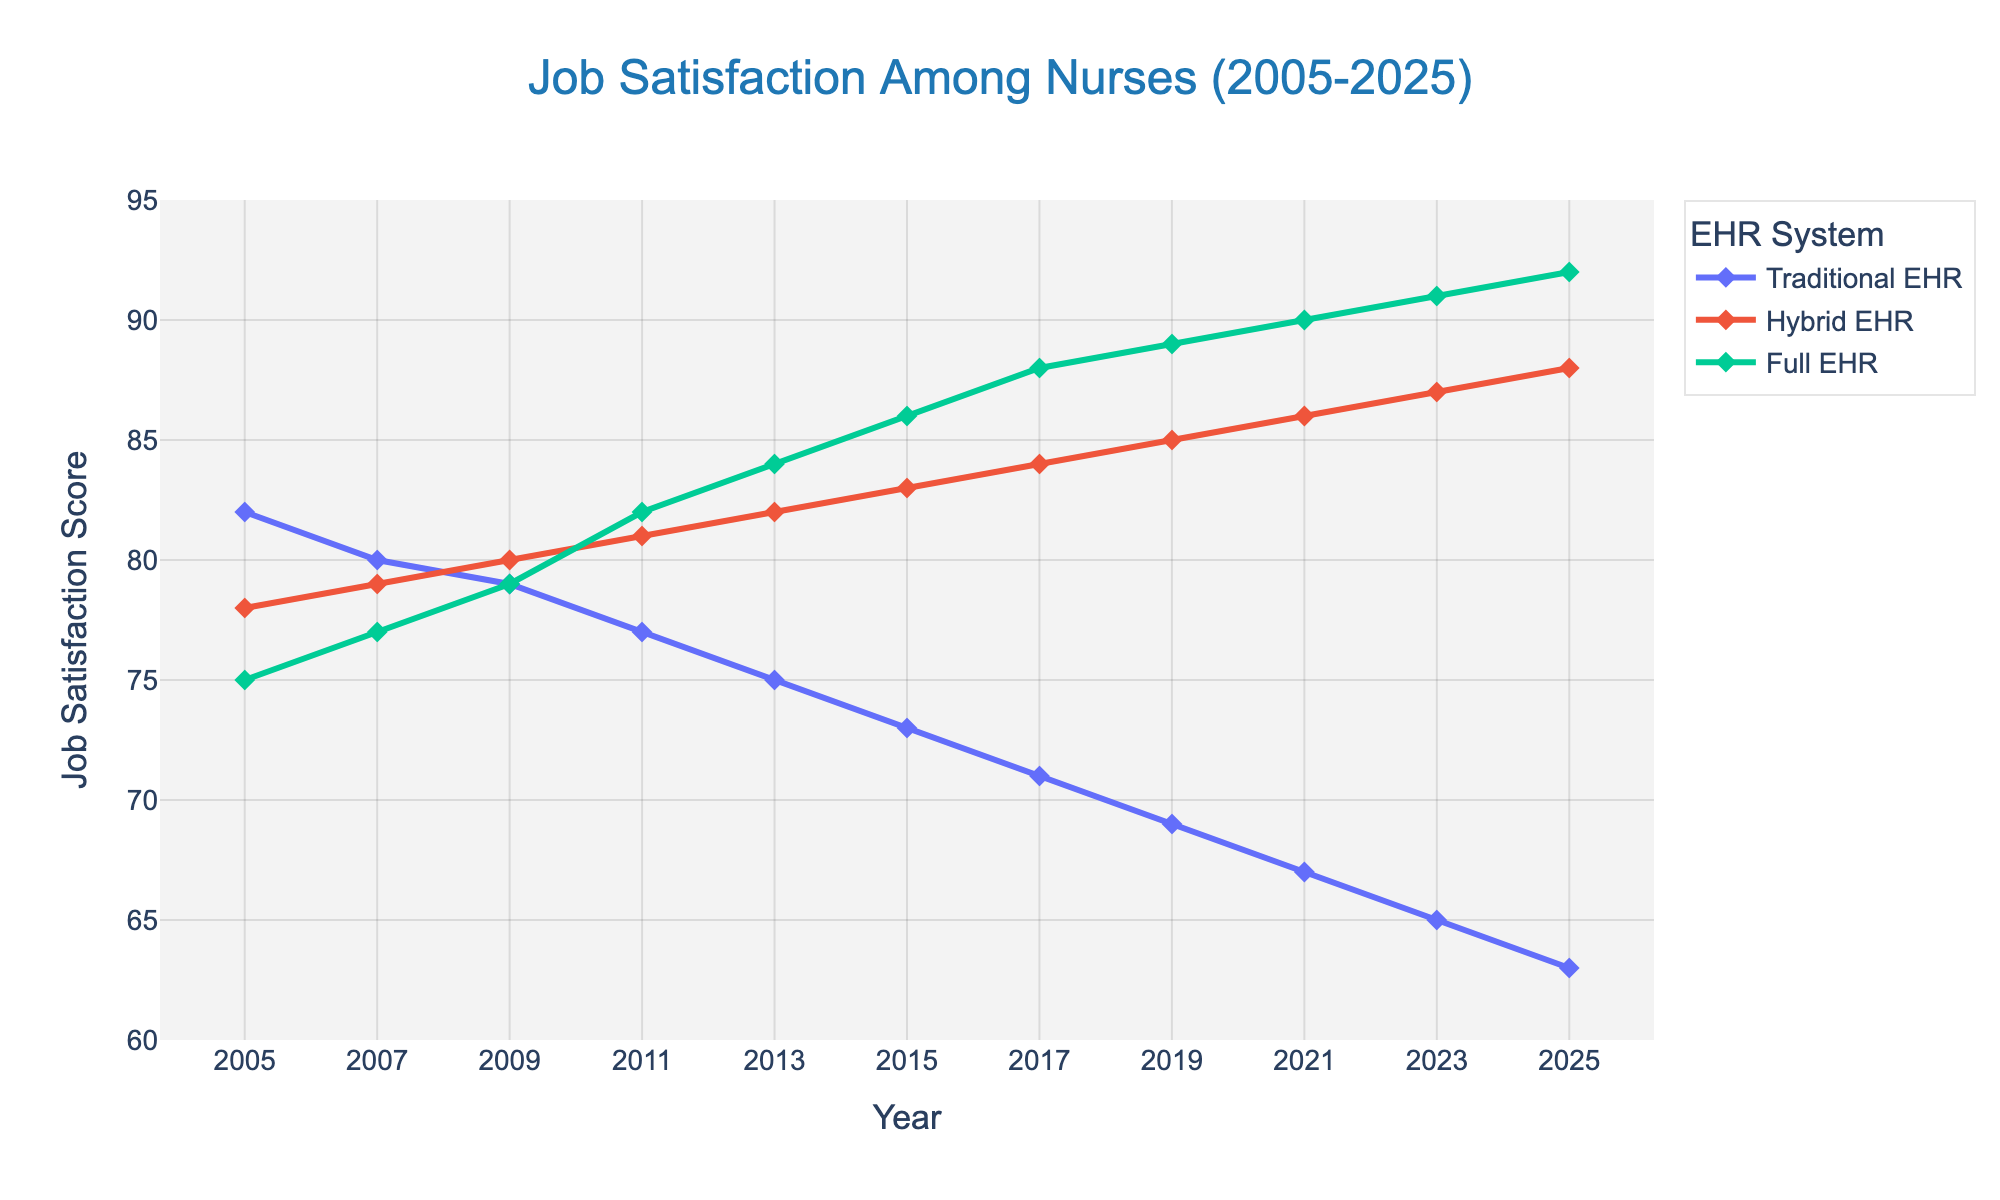What is the overall trend in job satisfaction for nurses using Traditional EHR from 2005 to 2025? From 2005 to 2025, job satisfaction for nurses using Traditional EHR shows a consistent downward trend. This can be observed by following the line representing Traditional EHR, which starts at 82 in 2005 and ends at 63 in 2025.
Answer: Downward trend In what year did the job satisfaction for Hybrid EHR surpass that of Traditional EHR? By comparing the lines on the chart, it's evident that Hybrid EHR surpassed Traditional EHR between 2007 and 2009. In 2007, the satisfaction scores were very close (79 for Hybrid and 80 for Traditional), and by 2009, Hybrid at 80 had surpassed Traditional at 79.
Answer: 2009 By how much did job satisfaction for Full EHR increase from 2005 to 2025? In 2005, the job satisfaction for Full EHR was 75. By 2025, it increased to 92. To find the difference: 92 - 75 = 17.
Answer: 17 Which EHR system had the highest job satisfaction in 2025? In 2025, by examining the endpoints of each line, Full EHR had the highest job satisfaction score of 92. The satisfaction scores for Traditional and Hybrid EHR were lower at 63 and 88, respectively.
Answer: Full EHR How does the job satisfaction score for Traditional EHR in 2015 compare to that of Full EHR in the same year? Looking at the figure for the year 2015, the job satisfaction score for Traditional EHR is 73, while for Full EHR, it is 86. The Full EHR score is significantly higher.
Answer: Full EHR is higher Between 2017 and 2021, which EHR system showed the highest relative increase in job satisfaction? Examining the slopes of each line segment between 2017 and 2021, Traditional EHR decreased from 71 to 67 (a decrease of 4 points). Hybrid EHR increased from 84 to 86 (an increase of 2 points). Full EHR increased from 88 to 90 (an increase of 2 points). So none showed a significant relative increase, but Hybrid and Full EHR both increased by 2 points.
Answer: Hybrid EHR and Full EHR What was the average job satisfaction score for nurses using Traditional EHR across all the years provided? To find the average, sum all job satisfaction scores for Traditional EHR (82 + 80 + 79 + 77 + 75 + 73 + 71 + 69 + 67 + 65 + 63) = 801. Then, divide by the number of years (11): 801 / 11 = approximately 72.82.
Answer: 72.82 How did the job satisfaction for nurses using Full EHR change between 2005 and 2011? In 2005, the job satisfaction for Full EHR was 75. By 2011, it increased to 82. The change is calculated as 82 - 75 = 7.
Answer: Increased by 7 What can you infer about the job satisfaction trend for Hybrid EHR from 2013 to 2025? The line for Hybrid EHR shows a consistent upward trend from 2013 (82) to 2025 (88). This indicates that job satisfaction for Hybrid EHR steadily increased over these years.
Answer: Upward trend Which year observed the smallest difference in job satisfaction scores between Hybrid and Full EHR? Visual comparison of the lines indicates that in 2007, the job satisfaction scores were closest with Hybrid at 79 and Full EHR at 77, giving a difference of 2. This is the smallest difference among the years shown.
Answer: 2007 